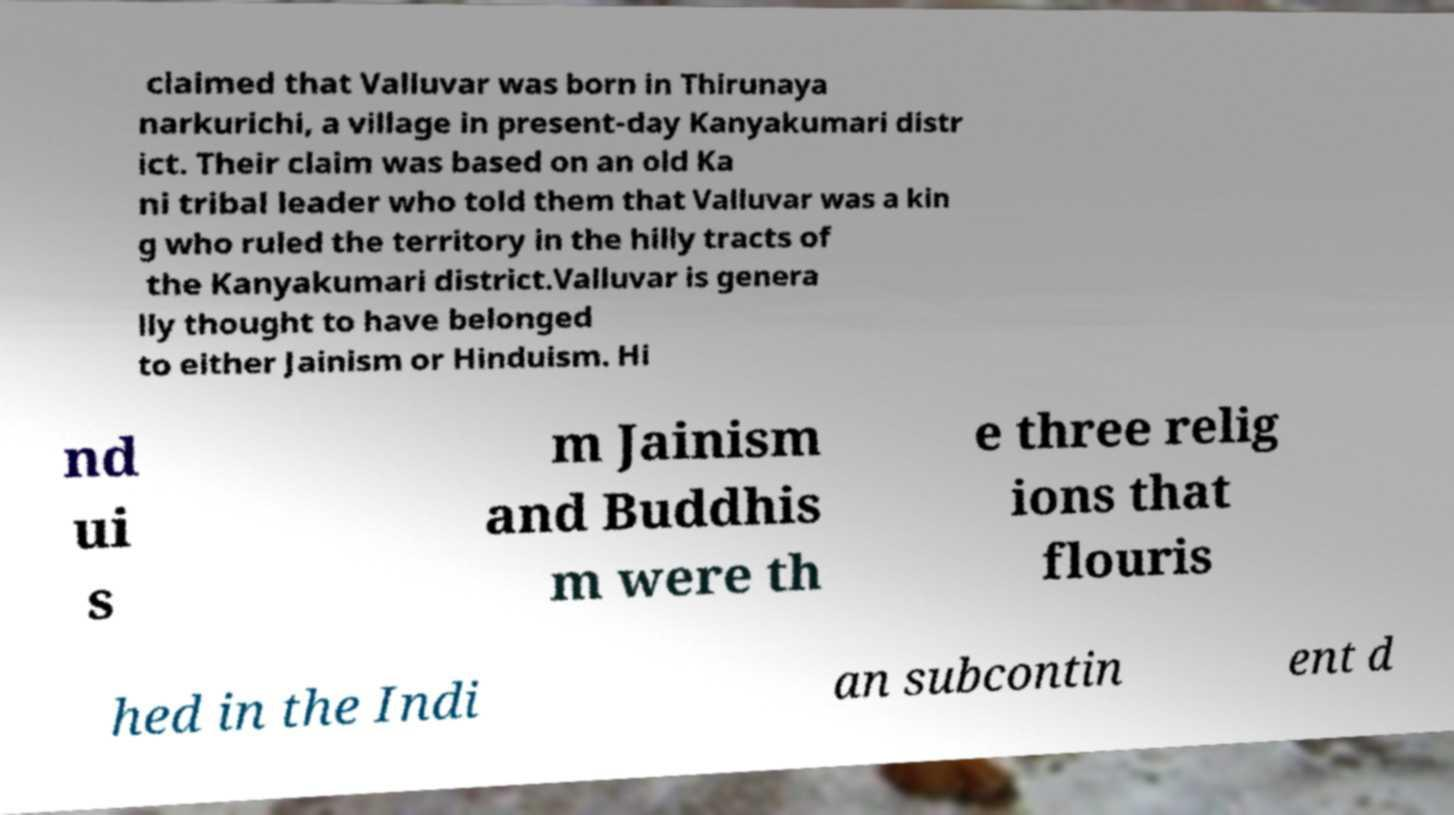I need the written content from this picture converted into text. Can you do that? claimed that Valluvar was born in Thirunaya narkurichi, a village in present-day Kanyakumari distr ict. Their claim was based on an old Ka ni tribal leader who told them that Valluvar was a kin g who ruled the territory in the hilly tracts of the Kanyakumari district.Valluvar is genera lly thought to have belonged to either Jainism or Hinduism. Hi nd ui s m Jainism and Buddhis m were th e three relig ions that flouris hed in the Indi an subcontin ent d 